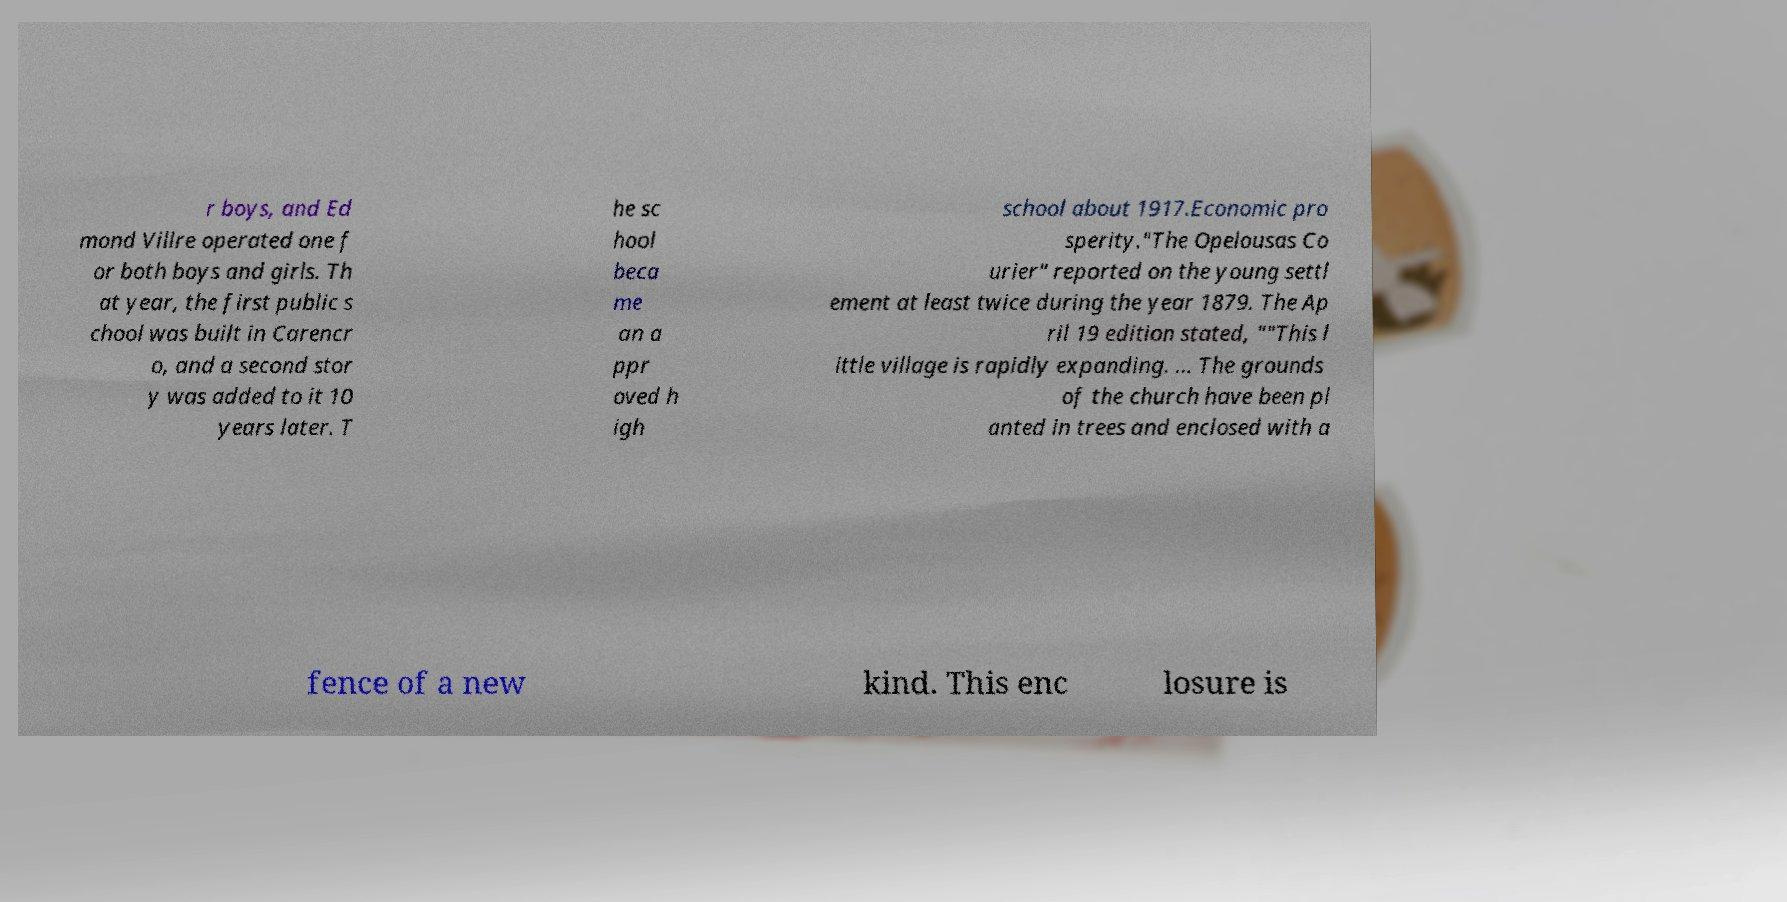Could you extract and type out the text from this image? r boys, and Ed mond Villre operated one f or both boys and girls. Th at year, the first public s chool was built in Carencr o, and a second stor y was added to it 10 years later. T he sc hool beca me an a ppr oved h igh school about 1917.Economic pro sperity."The Opelousas Co urier" reported on the young settl ement at least twice during the year 1879. The Ap ril 19 edition stated, ""This l ittle village is rapidly expanding. ... The grounds of the church have been pl anted in trees and enclosed with a fence of a new kind. This enc losure is 